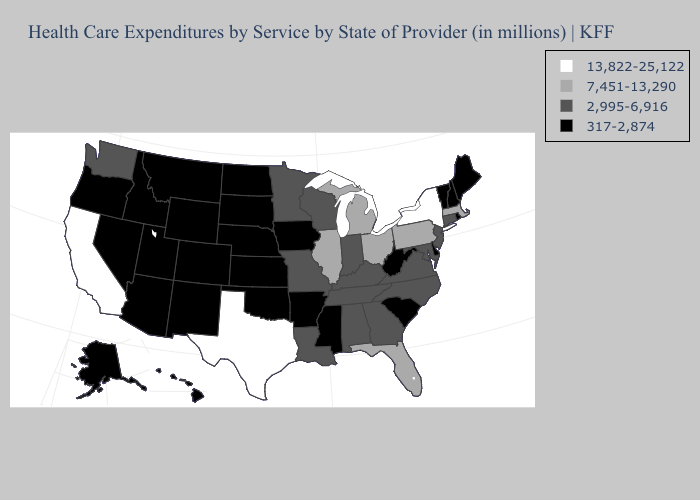What is the value of Connecticut?
Answer briefly. 2,995-6,916. What is the lowest value in states that border Minnesota?
Keep it brief. 317-2,874. Name the states that have a value in the range 7,451-13,290?
Keep it brief. Florida, Illinois, Massachusetts, Michigan, Ohio, Pennsylvania. Name the states that have a value in the range 13,822-25,122?
Short answer required. California, New York, Texas. Among the states that border Oklahoma , does Arkansas have the highest value?
Quick response, please. No. Which states hav the highest value in the MidWest?
Keep it brief. Illinois, Michigan, Ohio. Among the states that border Ohio , which have the highest value?
Write a very short answer. Michigan, Pennsylvania. Does California have the highest value in the West?
Short answer required. Yes. What is the value of Nevada?
Answer briefly. 317-2,874. Among the states that border Maryland , does West Virginia have the lowest value?
Write a very short answer. Yes. What is the highest value in the USA?
Quick response, please. 13,822-25,122. What is the value of Vermont?
Short answer required. 317-2,874. What is the value of Oregon?
Answer briefly. 317-2,874. Name the states that have a value in the range 7,451-13,290?
Concise answer only. Florida, Illinois, Massachusetts, Michigan, Ohio, Pennsylvania. Name the states that have a value in the range 2,995-6,916?
Be succinct. Alabama, Connecticut, Georgia, Indiana, Kentucky, Louisiana, Maryland, Minnesota, Missouri, New Jersey, North Carolina, Tennessee, Virginia, Washington, Wisconsin. 